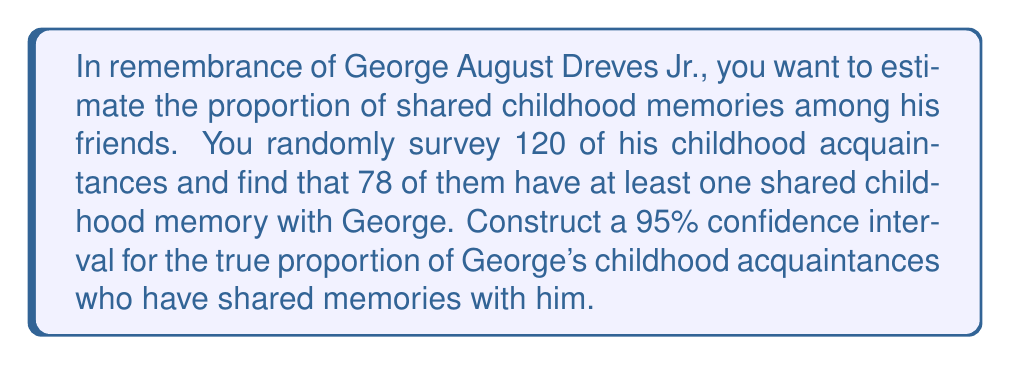Could you help me with this problem? Let's approach this step-by-step:

1) We're dealing with a population proportion, so we'll use the formula for a confidence interval of a proportion:

   $$\hat{p} \pm z^* \sqrt{\frac{\hat{p}(1-\hat{p})}{n}}$$

   Where:
   $\hat{p}$ is the sample proportion
   $z^*$ is the critical value
   $n$ is the sample size

2) Calculate $\hat{p}$:
   $$\hat{p} = \frac{78}{120} = 0.65$$

3) For a 95% confidence interval, $z^* = 1.96$

4) Plug these values into the formula:

   $$0.65 \pm 1.96 \sqrt{\frac{0.65(1-0.65)}{120}}$$

5) Simplify:
   $$0.65 \pm 1.96 \sqrt{\frac{0.2275}{120}}$$
   $$0.65 \pm 1.96 \sqrt{0.001896}$$
   $$0.65 \pm 1.96 (0.0435)$$
   $$0.65 \pm 0.0853$$

6) Calculate the interval:
   $$(0.65 - 0.0853, 0.65 + 0.0853)$$
   $$(0.5647, 0.7353)$$

Therefore, we can be 95% confident that the true proportion of George's childhood acquaintances who have shared memories with him is between 0.5647 and 0.7353, or approximately between 56.47% and 73.53%.
Answer: (0.5647, 0.7353) 